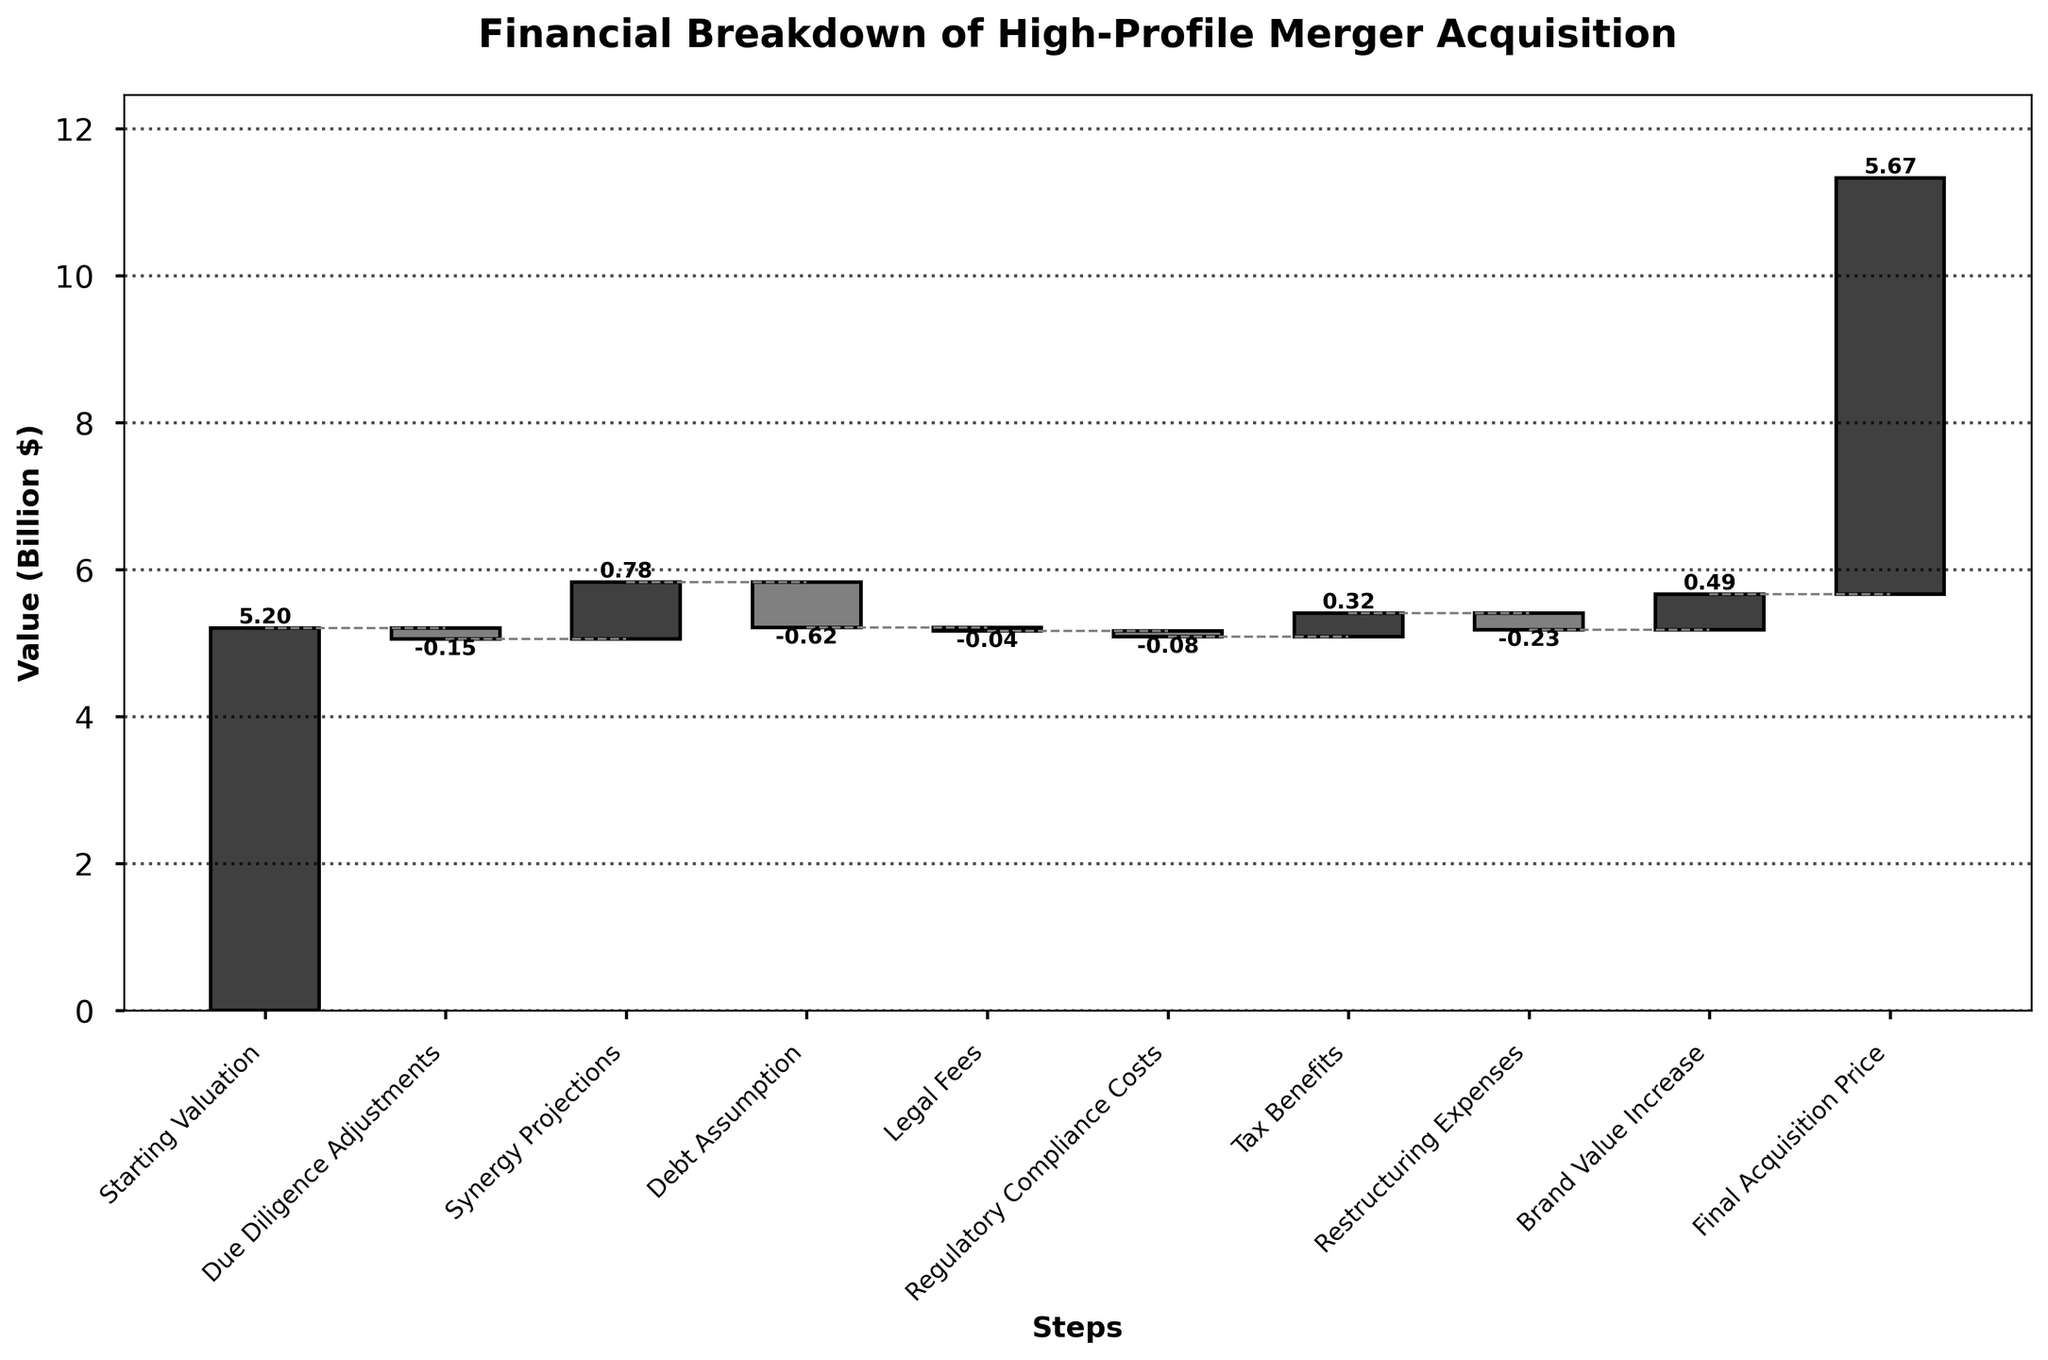what is the title of the figure? The title of the figure is typically displayed at the top, in a larger and bold font compared to other text elements. In this case, locate the title at the top center.
Answer: Financial Breakdown of High-Profile Merger Acquisition what is the value after the "Debt Assumption" step? To find the value after the "Debt Assumption" step, identify the bar labeled "Debt Assumption" and note the cumulative value at its top.
Answer: Approximately 4.78 Billion $ which step shows the highest increase in value? Assess all the positive changes indicated on the bars of the chart. The bar with the highest positive value represents the highest increase.
Answer: Synergy Projections with 0.78 Billion $ how much did legal fees and regulatory compliance costs reduce the value by? Sum the changes associated with "Legal Fees" and "Regulatory Compliance Costs." Both are negative changes (-0.045 and -0.08 respectively), so add them directly.
Answer: 0.125 Billion $ which steps involve a positive change in value? Identify all bars with positive values by observing the direction and labeling. Positive values are usually indicated by bars extending upwards.
Answer: Synergy Projections, Tax Benefits, Brand Value Increase after how many steps does the company's valuation actually rise above the starting valuation? Trace the cumulative value at each step and identify the first step where the cumulative value exceeds the initial starting valuation of 5.2 Billion $.
Answer: After the "Tax Benefits" step what is the total positive change in value? Sum all the positive changes by adding the values from "Synergy Projections," "Tax Benefits," and "Brand Value Increase."
Answer: 1.59 Billion $ comparing the "Restructuring Expenses" and "Debt Assumption," which has a larger impact on reducing the valuation? Both changes are negative, so compare the absolute values of "Restructuring Expenses" and "Debt Assumption."
Answer: Debt Assumption which step causes the valuation to drop the most? Identify the step with the largest negative change by looking for the bar with the greatest downward extent.
Answer: Debt Assumption 